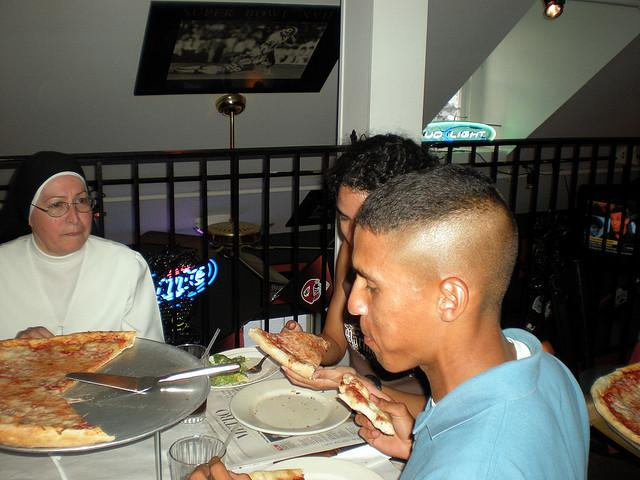What is this woman's profession? Please explain your reasoning. nun. The woman is a nun. 